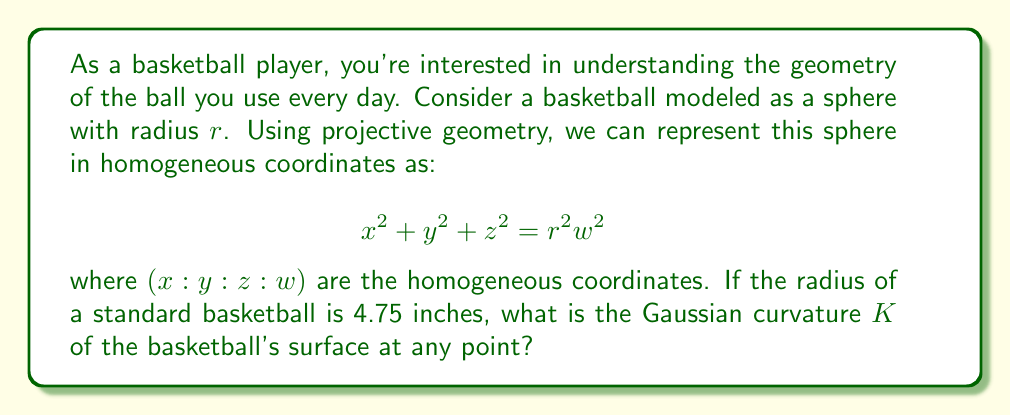Help me with this question. Let's approach this step-by-step:

1) The Gaussian curvature $K$ of a sphere is constant at every point on its surface.

2) For a sphere of radius $r$, the Gaussian curvature is given by:

   $$ K = \frac{1}{r^2} $$

3) This formula comes from differential geometry. It represents the product of the two principal curvatures of the sphere, which are both $\frac{1}{r}$ for a sphere.

4) We're given that the radius of a standard basketball is 4.75 inches.

5) Substituting this value into our formula:

   $$ K = \frac{1}{(4.75)^2} = \frac{1}{22.5625} \approx 0.0443 \text{ in}^{-2} $$

6) Note that the units of Gaussian curvature are the inverse square of the units of length. In this case, it's square inches $(\text{in}^2)$ inverted to $\text{in}^{-2}$.

This constant curvature is a key property of spheres and explains why a basketball maintains its shape uniformly across its surface.
Answer: $K = \frac{1}{(4.75)^2} \approx 0.0443 \text{ in}^{-2}$ 